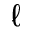<formula> <loc_0><loc_0><loc_500><loc_500>\ell</formula> 